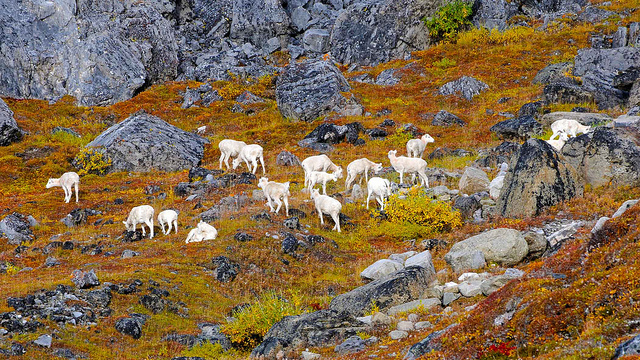Can you tell what species these animals are? Based on the image, these white-furred animals are most likely mountain goats, which are well adapted to steep and rugged environments. What adaptations do mountain goats have for this environment? Mountain goats have specialized hooves with inner pads that provide grip and cloven outer toes that can spread out to improve balance on rocky surfaces. Their thick white fur helps with insulation in cold weather, and their agility helps them navigate the difficult terrain to evade predators. 